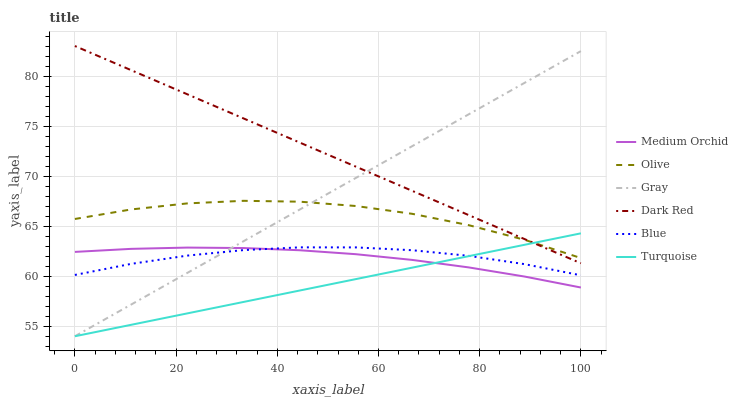Does Turquoise have the minimum area under the curve?
Answer yes or no. Yes. Does Dark Red have the maximum area under the curve?
Answer yes or no. Yes. Does Gray have the minimum area under the curve?
Answer yes or no. No. Does Gray have the maximum area under the curve?
Answer yes or no. No. Is Turquoise the smoothest?
Answer yes or no. Yes. Is Olive the roughest?
Answer yes or no. Yes. Is Gray the smoothest?
Answer yes or no. No. Is Gray the roughest?
Answer yes or no. No. Does Gray have the lowest value?
Answer yes or no. Yes. Does Dark Red have the lowest value?
Answer yes or no. No. Does Dark Red have the highest value?
Answer yes or no. Yes. Does Gray have the highest value?
Answer yes or no. No. Is Medium Orchid less than Olive?
Answer yes or no. Yes. Is Dark Red greater than Medium Orchid?
Answer yes or no. Yes. Does Medium Orchid intersect Blue?
Answer yes or no. Yes. Is Medium Orchid less than Blue?
Answer yes or no. No. Is Medium Orchid greater than Blue?
Answer yes or no. No. Does Medium Orchid intersect Olive?
Answer yes or no. No. 